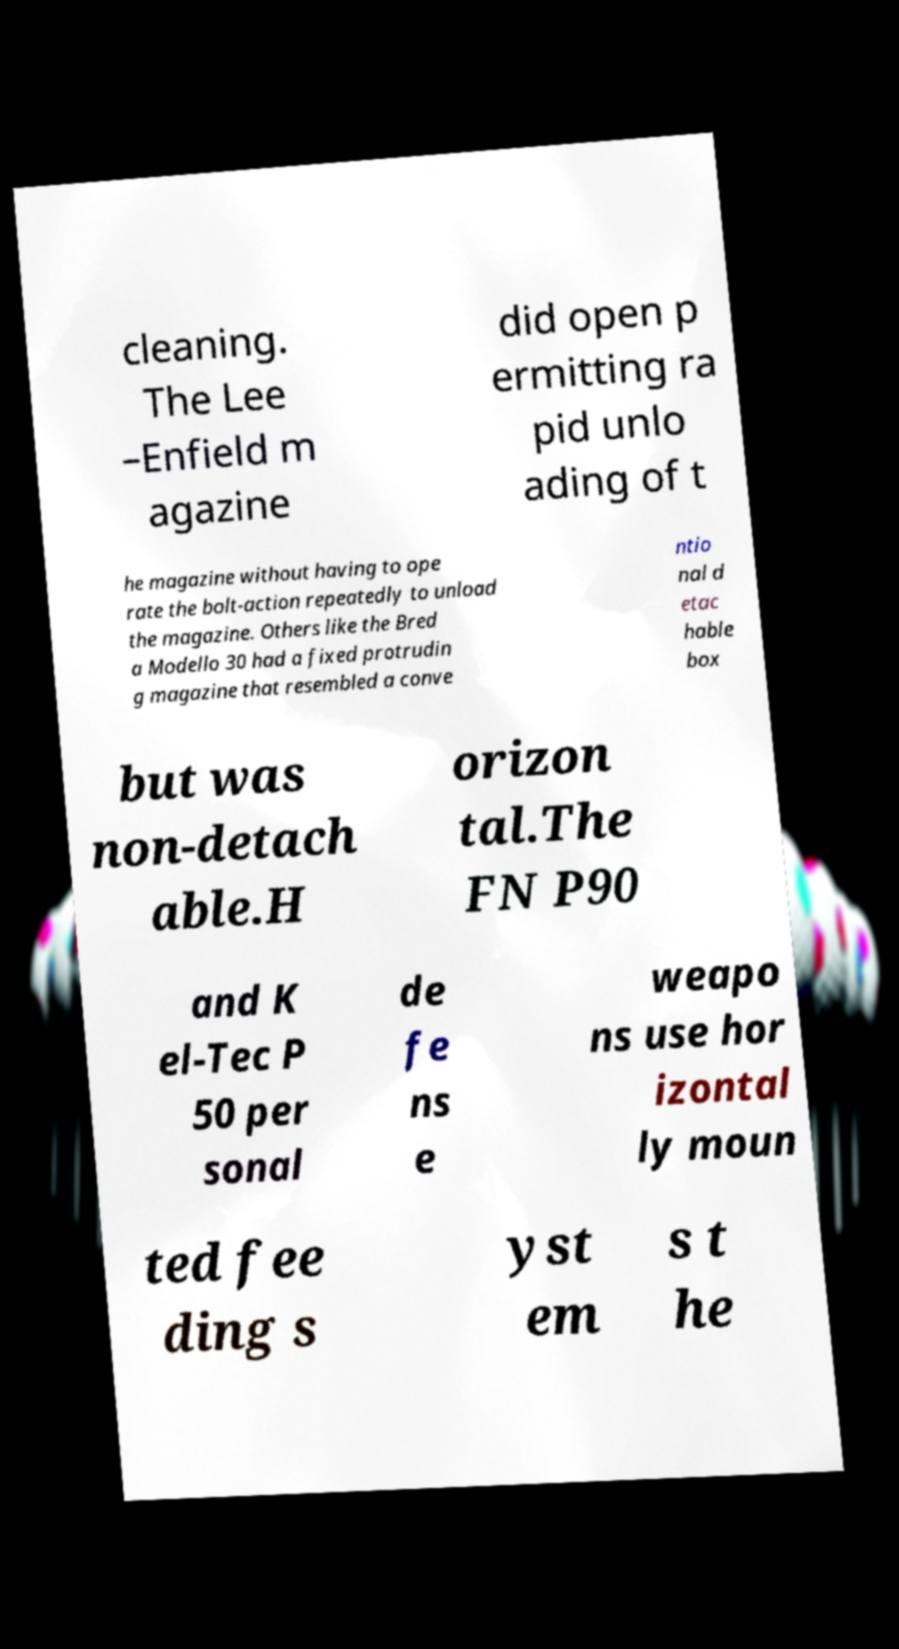Please read and relay the text visible in this image. What does it say? cleaning. The Lee –Enfield m agazine did open p ermitting ra pid unlo ading of t he magazine without having to ope rate the bolt-action repeatedly to unload the magazine. Others like the Bred a Modello 30 had a fixed protrudin g magazine that resembled a conve ntio nal d etac hable box but was non-detach able.H orizon tal.The FN P90 and K el-Tec P 50 per sonal de fe ns e weapo ns use hor izontal ly moun ted fee ding s yst em s t he 